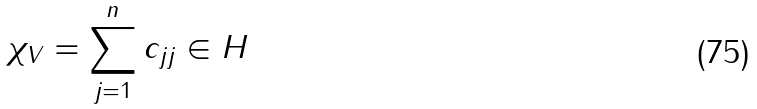<formula> <loc_0><loc_0><loc_500><loc_500>\chi _ { V } = \sum _ { j = 1 } ^ { n } c _ { j j } \in H</formula> 